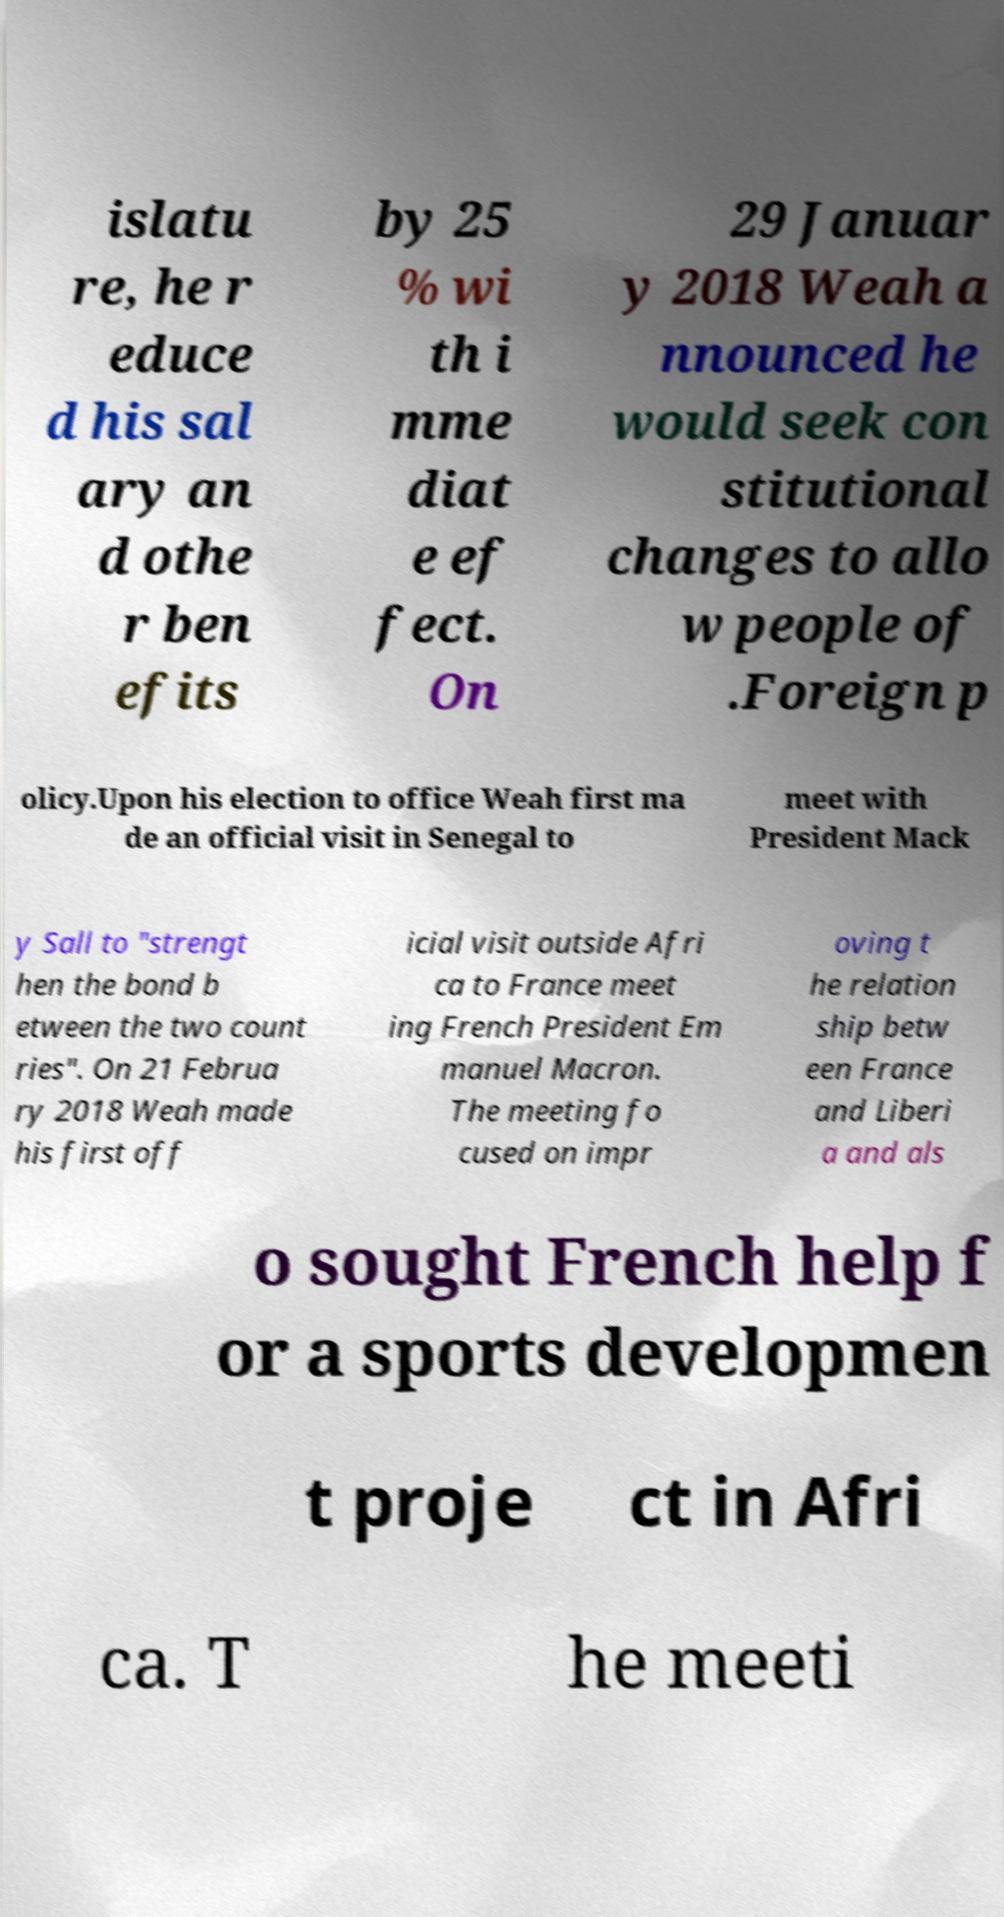Could you extract and type out the text from this image? islatu re, he r educe d his sal ary an d othe r ben efits by 25 % wi th i mme diat e ef fect. On 29 Januar y 2018 Weah a nnounced he would seek con stitutional changes to allo w people of .Foreign p olicy.Upon his election to office Weah first ma de an official visit in Senegal to meet with President Mack y Sall to "strengt hen the bond b etween the two count ries". On 21 Februa ry 2018 Weah made his first off icial visit outside Afri ca to France meet ing French President Em manuel Macron. The meeting fo cused on impr oving t he relation ship betw een France and Liberi a and als o sought French help f or a sports developmen t proje ct in Afri ca. T he meeti 